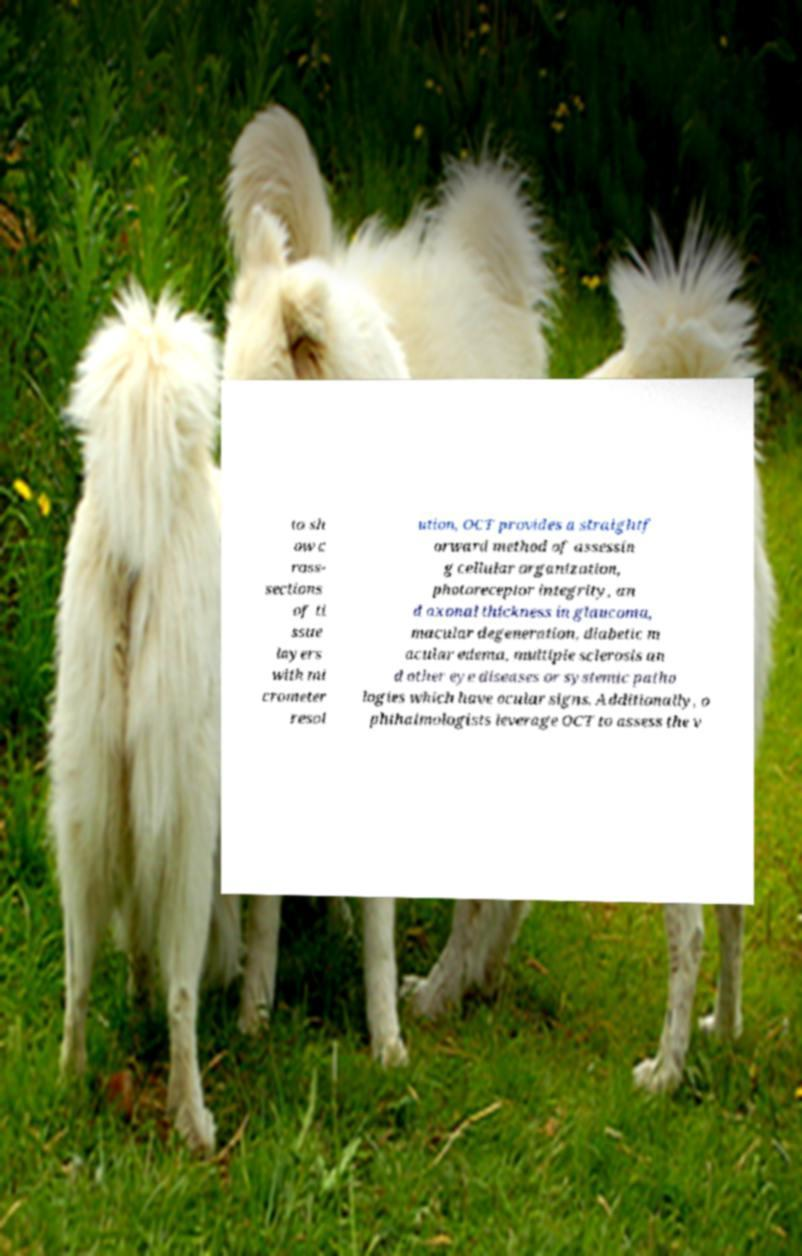Can you read and provide the text displayed in the image?This photo seems to have some interesting text. Can you extract and type it out for me? to sh ow c ross- sections of ti ssue layers with mi crometer resol ution, OCT provides a straightf orward method of assessin g cellular organization, photoreceptor integrity, an d axonal thickness in glaucoma, macular degeneration, diabetic m acular edema, multiple sclerosis an d other eye diseases or systemic patho logies which have ocular signs. Additionally, o phthalmologists leverage OCT to assess the v 